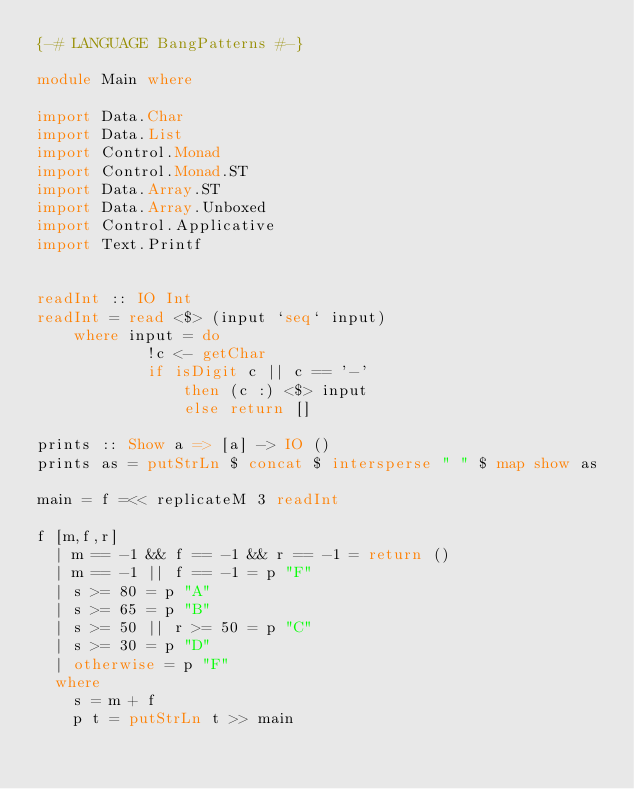<code> <loc_0><loc_0><loc_500><loc_500><_Haskell_>{-# LANGUAGE BangPatterns #-}

module Main where

import Data.Char
import Data.List
import Control.Monad
import Control.Monad.ST
import Data.Array.ST
import Data.Array.Unboxed
import Control.Applicative
import Text.Printf


readInt :: IO Int
readInt = read <$> (input `seq` input)
    where input = do
            !c <- getChar
            if isDigit c || c == '-'
                then (c :) <$> input
                else return []

prints :: Show a => [a] -> IO ()
prints as = putStrLn $ concat $ intersperse " " $ map show as

main = f =<< replicateM 3 readInt

f [m,f,r]
  | m == -1 && f == -1 && r == -1 = return ()
  | m == -1 || f == -1 = p "F"
  | s >= 80 = p "A"
  | s >= 65 = p "B"
  | s >= 50 || r >= 50 = p "C"
  | s >= 30 = p "D"
  | otherwise = p "F"
  where
    s = m + f
    p t = putStrLn t >> main
</code> 